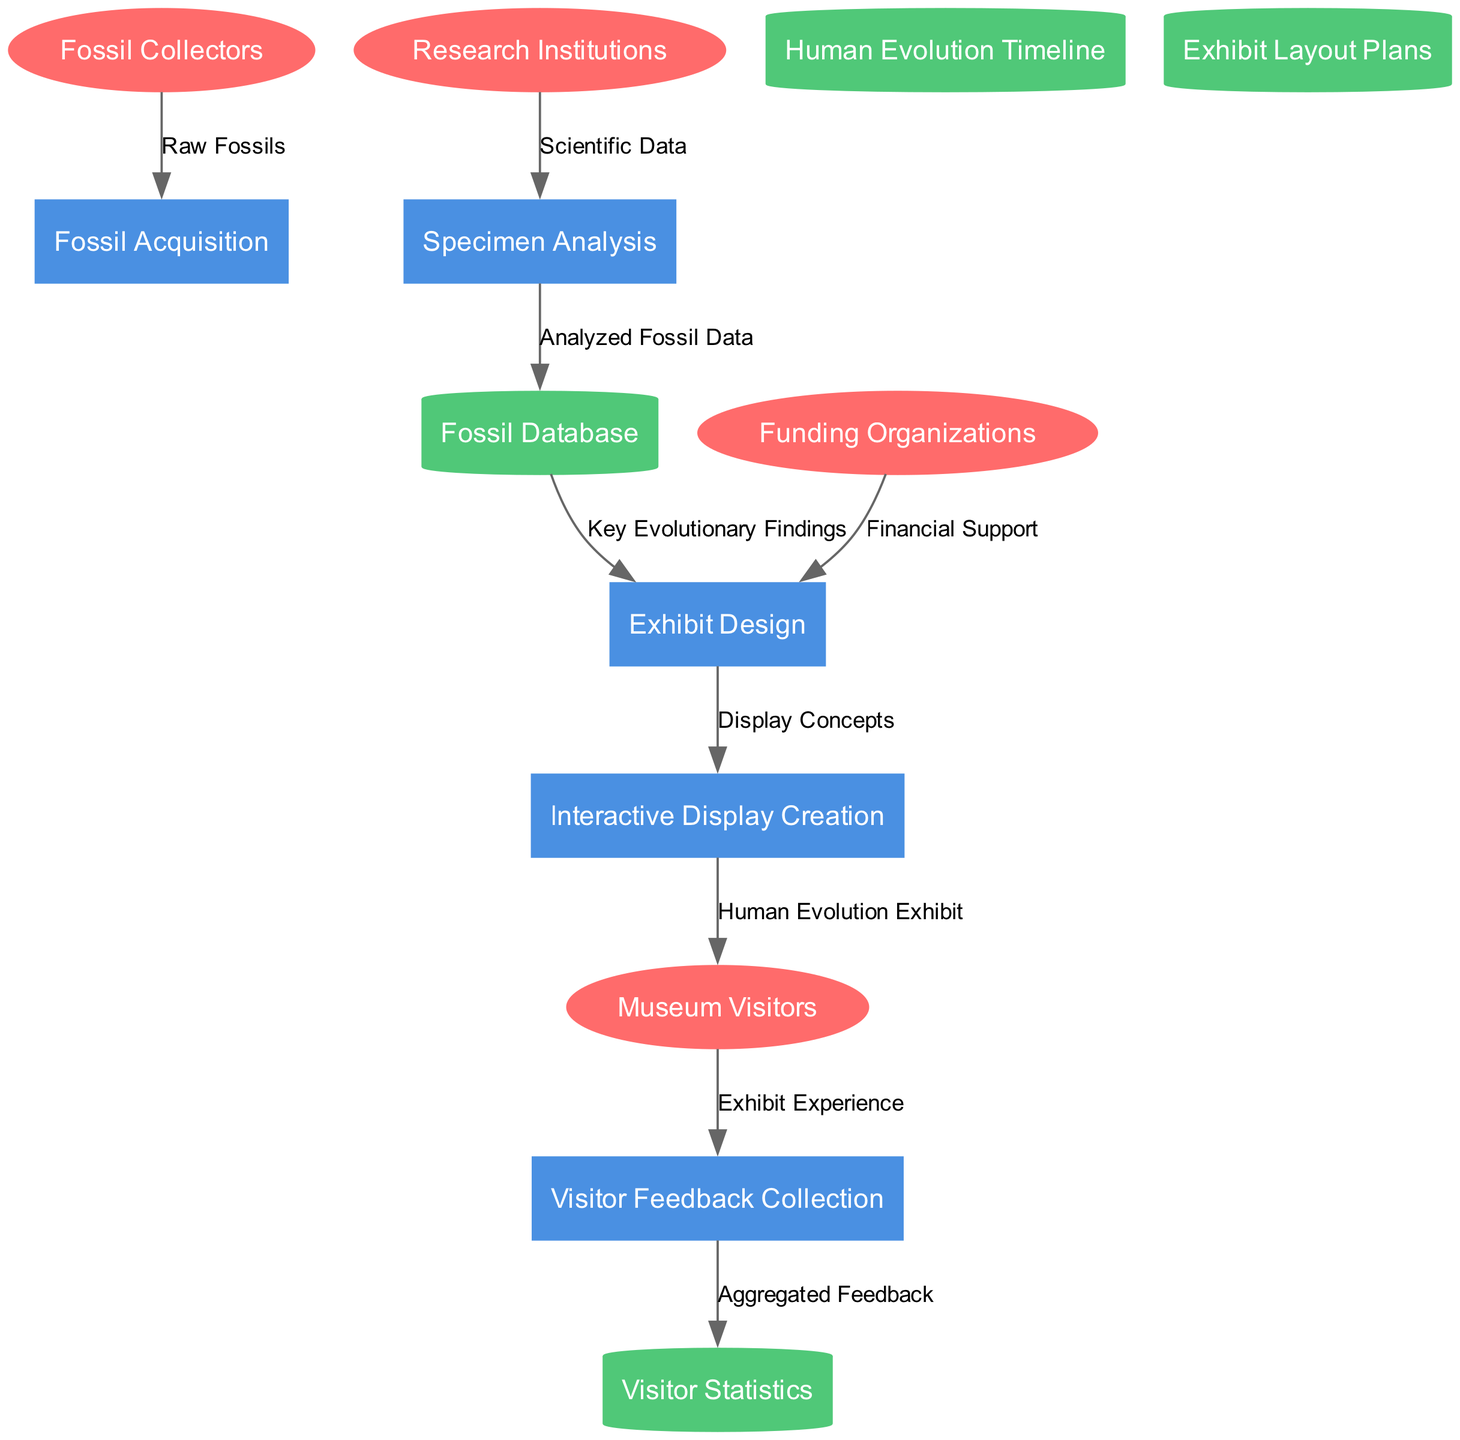What are the external entities in the diagram? The diagram lists four external entities: Fossil Collectors, Research Institutions, Museum Visitors, and Funding Organizations. These are displayed as ellipses in the diagram.
Answer: Fossil Collectors, Research Institutions, Museum Visitors, Funding Organizations How many processes are shown in the diagram? The diagram includes five processes related to the human evolution exhibit: Fossil Acquisition, Specimen Analysis, Exhibit Design, Interactive Display Creation, and Visitor Feedback Collection. Counting them results in a total of five distinct processes.
Answer: 5 What type of data is received from Fossil Collectors? The Fossil Collectors provide a specific type of data labeled "Raw Fossils," which indicates the initial materials collected for further processing.
Answer: Raw Fossils Which process is directly after Specimen Analysis in the data flow? Following Specimen Analysis, the next process in the flow is Fossil Database. This indicates that analyzed data transitions into a storage entity before further use in exhibit design.
Answer: Fossil Database What do Funding Organizations provide to the Exhibit Design process? Funding Organizations contribute "Financial Support" to the Exhibit Design process, which is essential for developing the exhibit itself. This demonstrates the external support system in place.
Answer: Financial Support How does Visitor Feedback Collection relate to Visitor Statistics? Visitor Feedback Collection sends "Aggregated Feedback" to the Visitor Statistics data store, which consolidates visitor experiences and input for analysis and future improvements. This shows the feedback loop from visitors to exhibit improvement initiatives.
Answer: Aggregated Feedback Which process generates the Human Evolution Exhibit for Museum Visitors? The Interactive Display Creation process is responsible for generating the Human Evolution Exhibit intended for the Museum Visitors, illustrating the journey of content development from an idea to visitor engagement.
Answer: Interactive Display Creation Which data store receives the output of Specimen Analysis? The Fossil Database receives the output from Specimen Analysis, as it holds the analyzed fossil data that informs further processes down the line. This highlights the sequential flow of data storage following analyses.
Answer: Fossil Database From which process does Exhibit Design receive key information? Exhibit Design receives "Key Evolutionary Findings" from the Fossil Database, illustrating how information is built upon prior analyses for the design of the exhibit.
Answer: Fossil Database 